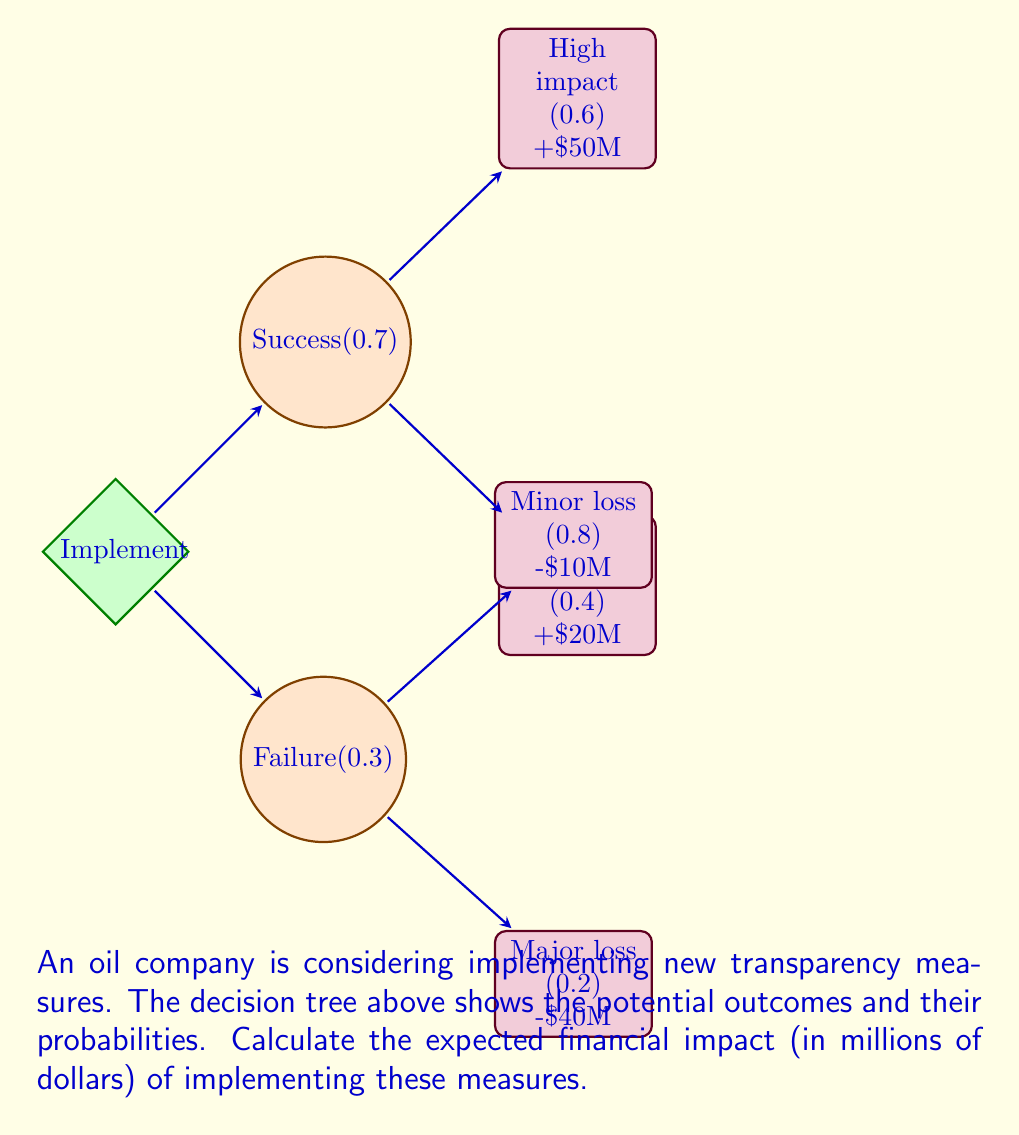Provide a solution to this math problem. To calculate the expected financial impact, we need to multiply each outcome by its probability and sum the results. Let's break it down step-by-step:

1) For the success branch (probability 0.7):
   a) High impact: $0.7 \times 0.6 \times \$50M = \$21M$
   b) Low impact: $0.7 \times 0.4 \times \$20M = \$5.6M$

2) For the failure branch (probability 0.3):
   a) Minor loss: $0.3 \times 0.8 \times (-\$10M) = -\$2.4M$
   b) Major loss: $0.3 \times 0.2 \times (-\$40M) = -\$2.4M$

3) Sum all the expected values:

   $$E = \$21M + \$5.6M + (-\$2.4M) + (-\$2.4M)$$

4) Simplify:

   $$E = \$21.8M$$

Therefore, the expected financial impact of implementing the transparency measures is $21.8 million.
Answer: $21.8 million 